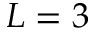<formula> <loc_0><loc_0><loc_500><loc_500>L = 3</formula> 